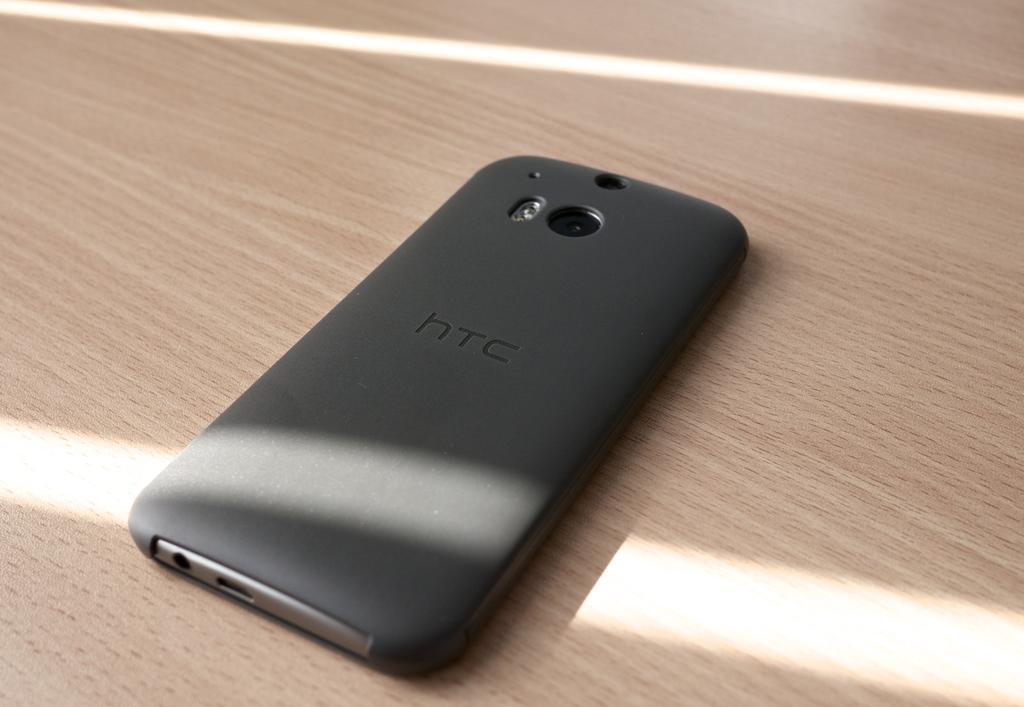<image>
Render a clear and concise summary of the photo. A htc black cell phone upside down on a brown surface. 